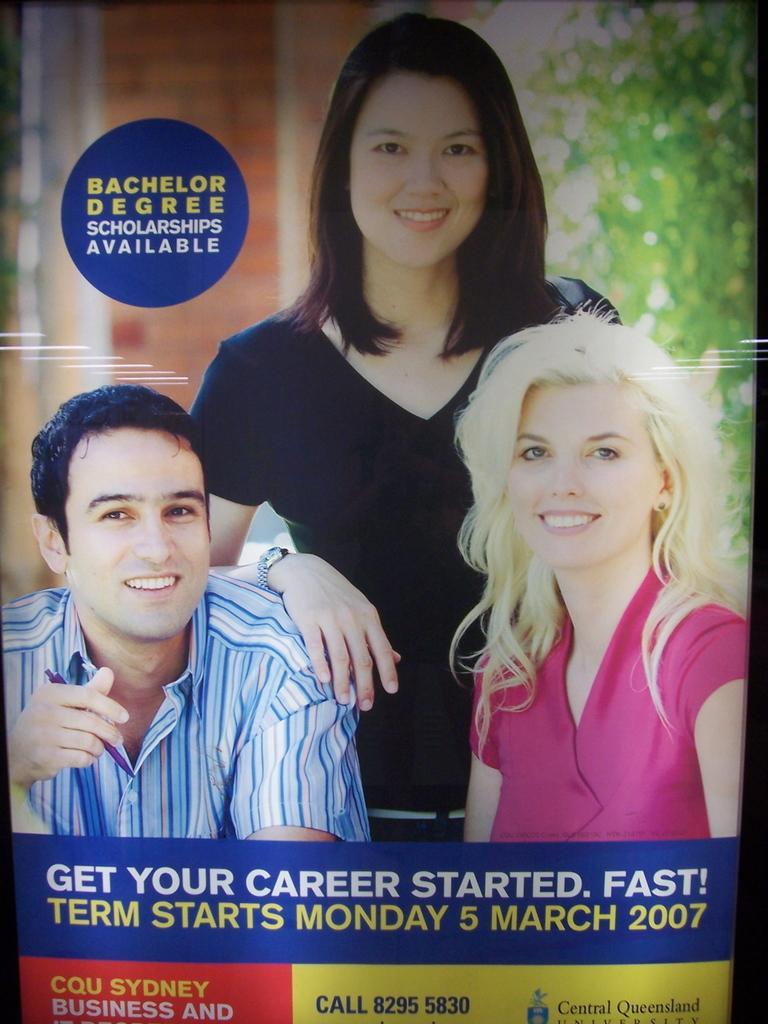Please provide a concise description of this image. This picture contains a poster. In this picture, we see a man in blue shirt and a woman in pink dress is sitting. Behind them, the woman in black T-shirt is standing. All of the are smiling. Behind them, we see trees and a wall or a pillar. At the bottom of the picture, we see some text written. 